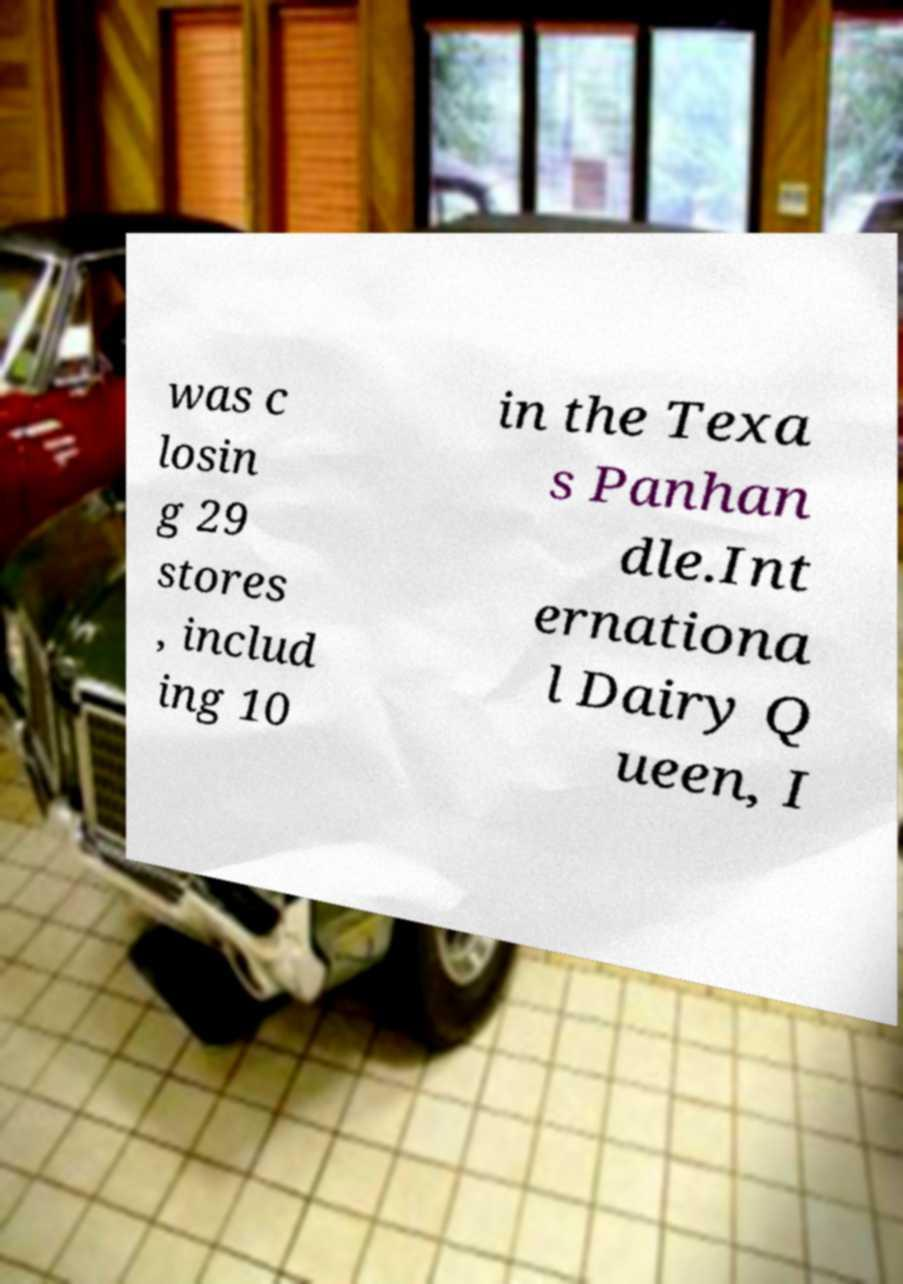Can you accurately transcribe the text from the provided image for me? was c losin g 29 stores , includ ing 10 in the Texa s Panhan dle.Int ernationa l Dairy Q ueen, I 